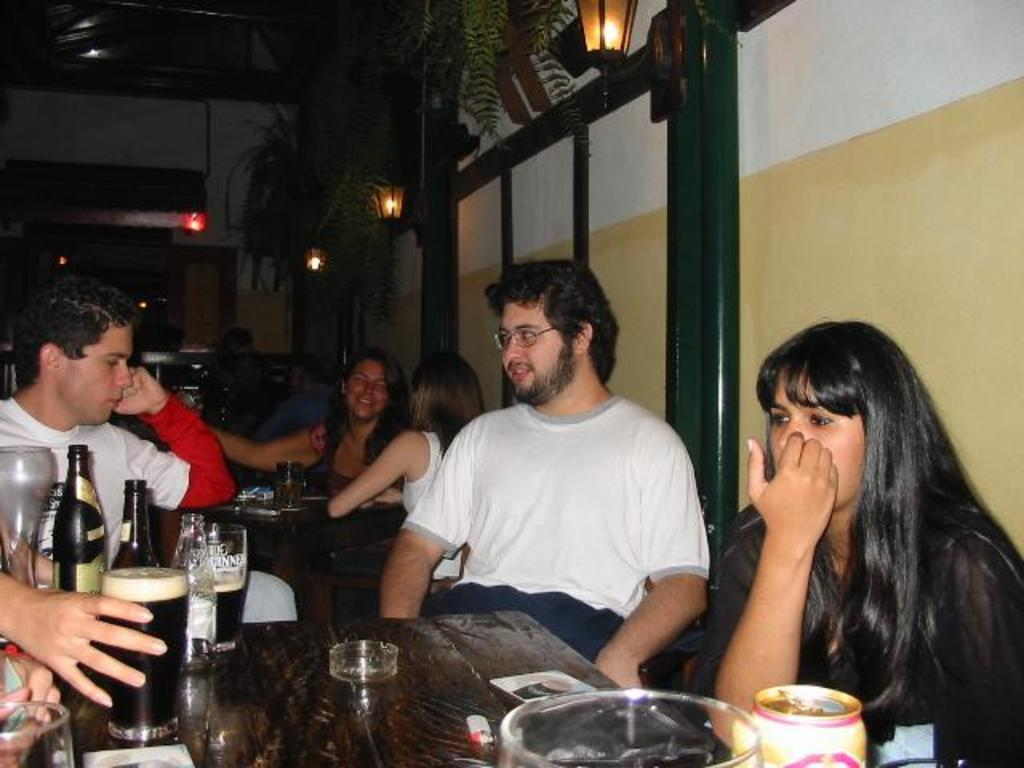What is happening in the image? There is a group of people in the image, and they are seated. What can be seen on the table in front of the people? There are glasses and beer bottles on the table. What type of development is taking place in the north of the image? There is no development or reference to a north direction in the image; it features a group of people seated at a table with glasses and beer bottles. 